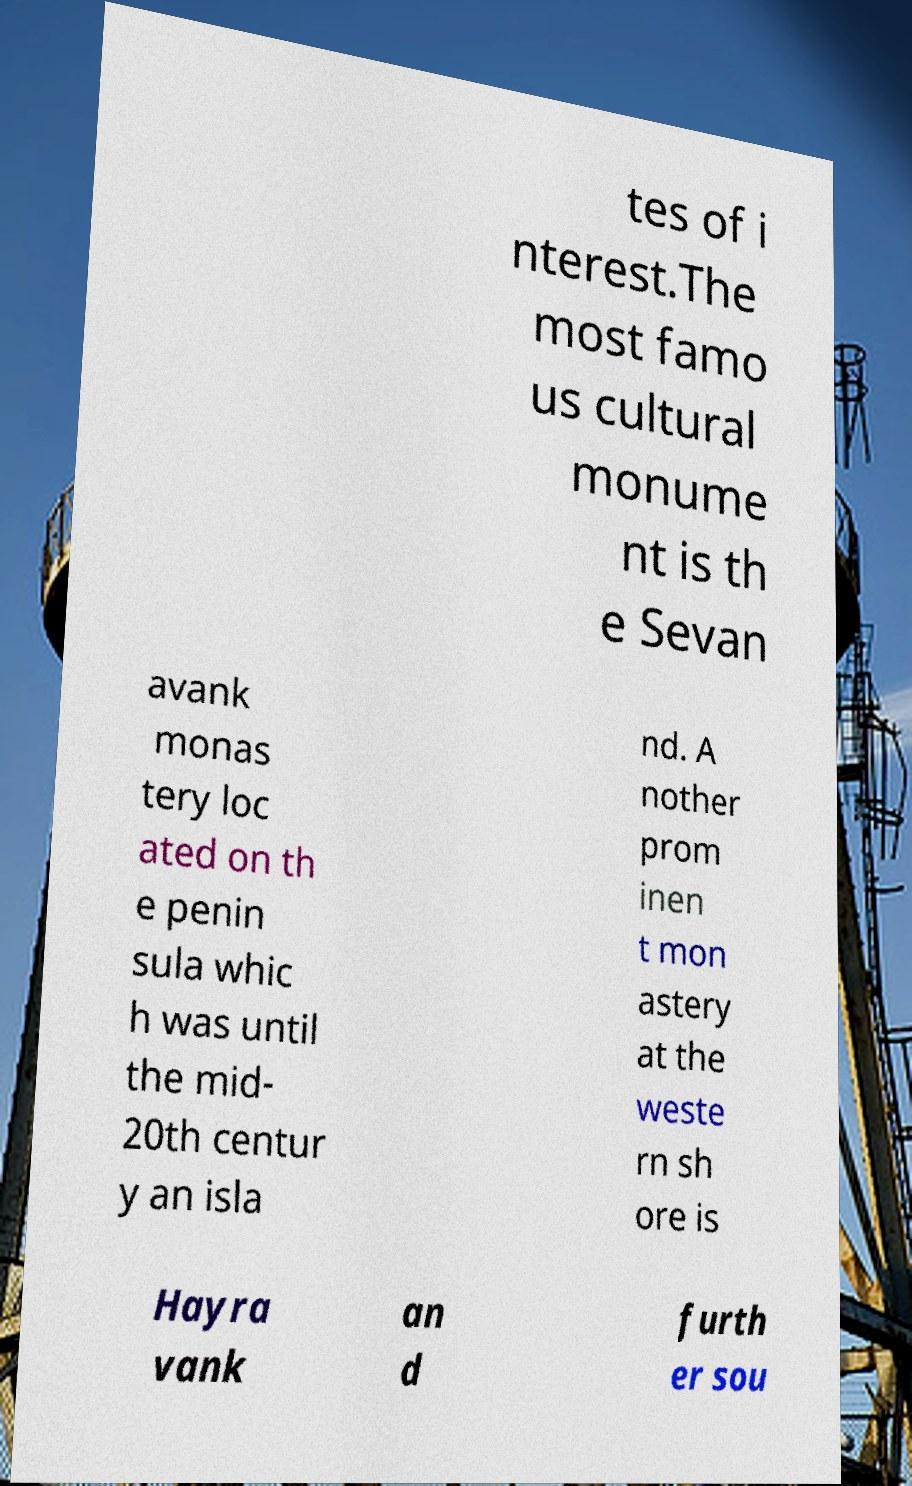There's text embedded in this image that I need extracted. Can you transcribe it verbatim? tes of i nterest.The most famo us cultural monume nt is th e Sevan avank monas tery loc ated on th e penin sula whic h was until the mid- 20th centur y an isla nd. A nother prom inen t mon astery at the weste rn sh ore is Hayra vank an d furth er sou 